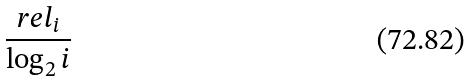<formula> <loc_0><loc_0><loc_500><loc_500>\frac { r e l _ { i } } { \log _ { 2 } i }</formula> 